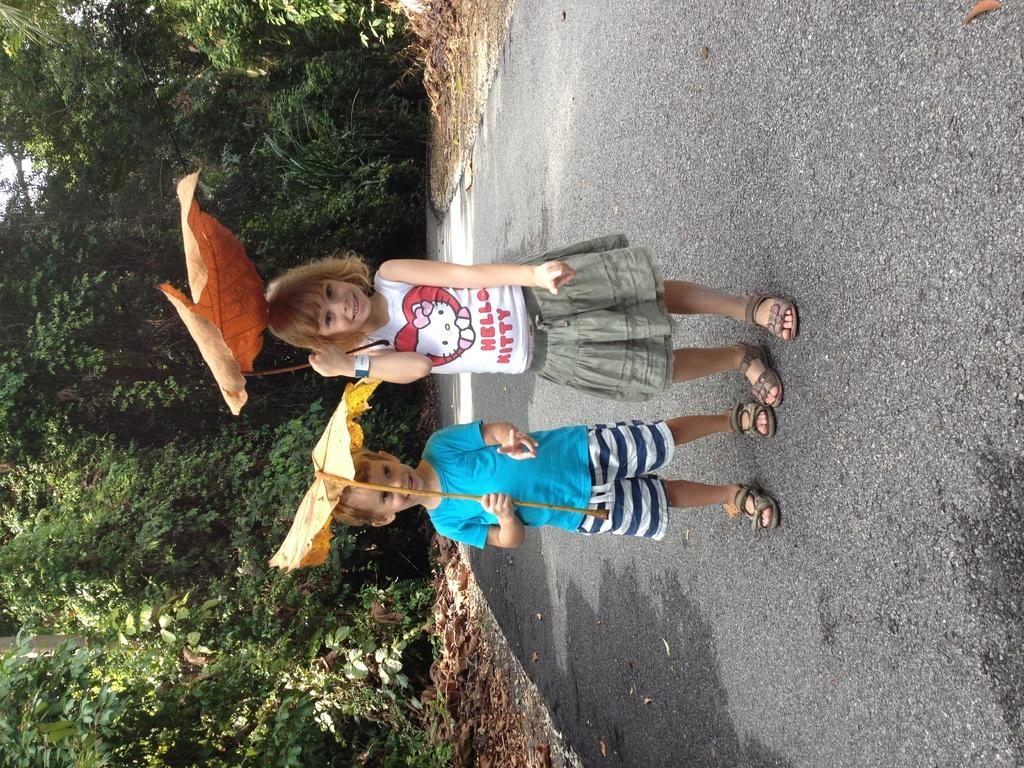<image>
Present a compact description of the photo's key features. A little girl in a Hello Kitty shirt stands next to a little boy. 